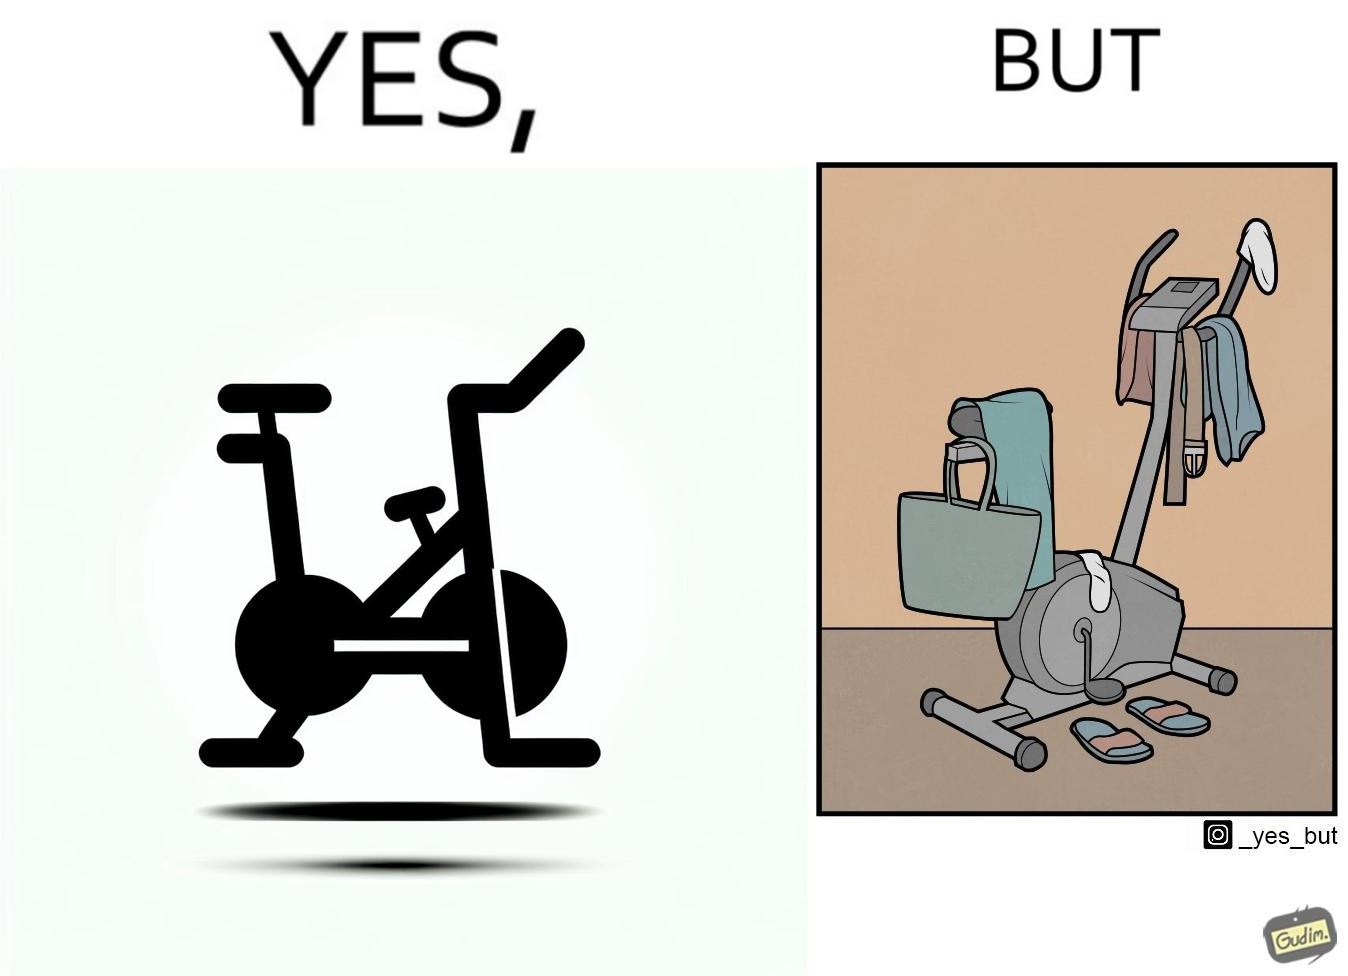What is shown in this image? The images are funny since they show an exercise bike has been bought but is not being used for its purpose, that is, exercising. It is rather being used to hang clothes, bags and other items 